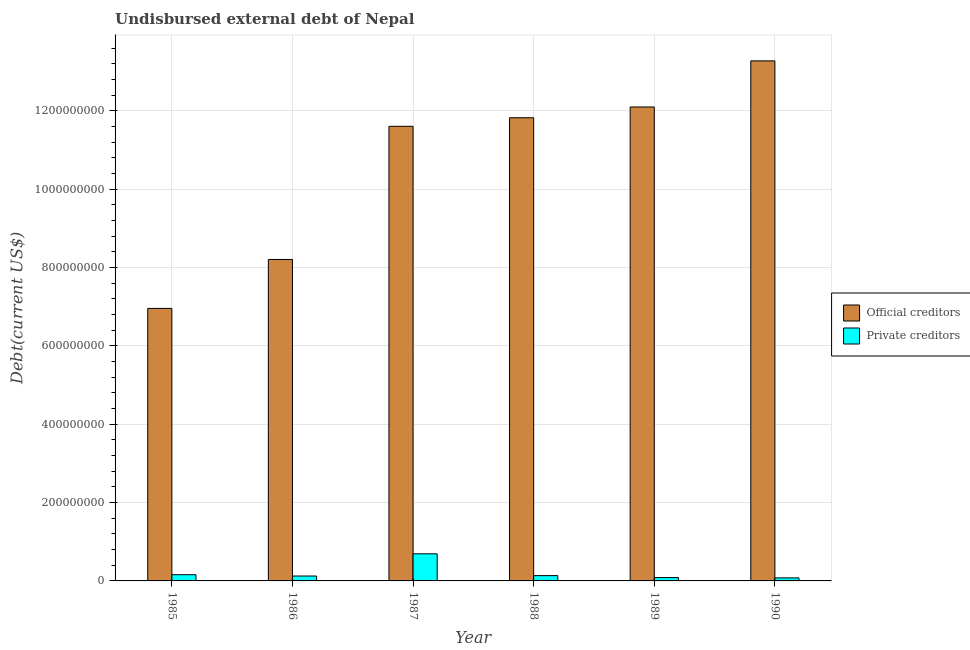Are the number of bars per tick equal to the number of legend labels?
Provide a succinct answer. Yes. Are the number of bars on each tick of the X-axis equal?
Your answer should be compact. Yes. How many bars are there on the 6th tick from the left?
Provide a succinct answer. 2. In how many cases, is the number of bars for a given year not equal to the number of legend labels?
Your answer should be compact. 0. What is the undisbursed external debt of private creditors in 1986?
Provide a short and direct response. 1.25e+07. Across all years, what is the maximum undisbursed external debt of private creditors?
Offer a terse response. 6.92e+07. Across all years, what is the minimum undisbursed external debt of private creditors?
Your response must be concise. 7.70e+06. In which year was the undisbursed external debt of private creditors minimum?
Make the answer very short. 1990. What is the total undisbursed external debt of official creditors in the graph?
Make the answer very short. 6.39e+09. What is the difference between the undisbursed external debt of private creditors in 1988 and that in 1990?
Ensure brevity in your answer.  5.80e+06. What is the difference between the undisbursed external debt of private creditors in 1990 and the undisbursed external debt of official creditors in 1986?
Ensure brevity in your answer.  -4.81e+06. What is the average undisbursed external debt of official creditors per year?
Provide a succinct answer. 1.07e+09. In how many years, is the undisbursed external debt of official creditors greater than 1240000000 US$?
Offer a terse response. 1. What is the ratio of the undisbursed external debt of private creditors in 1985 to that in 1989?
Keep it short and to the point. 1.86. Is the difference between the undisbursed external debt of private creditors in 1988 and 1990 greater than the difference between the undisbursed external debt of official creditors in 1988 and 1990?
Provide a short and direct response. No. What is the difference between the highest and the second highest undisbursed external debt of official creditors?
Your answer should be compact. 1.18e+08. What is the difference between the highest and the lowest undisbursed external debt of private creditors?
Your answer should be very brief. 6.15e+07. In how many years, is the undisbursed external debt of private creditors greater than the average undisbursed external debt of private creditors taken over all years?
Offer a very short reply. 1. What does the 2nd bar from the left in 1989 represents?
Keep it short and to the point. Private creditors. What does the 2nd bar from the right in 1990 represents?
Your answer should be compact. Official creditors. How many bars are there?
Keep it short and to the point. 12. How many years are there in the graph?
Give a very brief answer. 6. Does the graph contain grids?
Offer a very short reply. Yes. How many legend labels are there?
Offer a very short reply. 2. What is the title of the graph?
Offer a terse response. Undisbursed external debt of Nepal. What is the label or title of the Y-axis?
Your answer should be very brief. Debt(current US$). What is the Debt(current US$) in Official creditors in 1985?
Ensure brevity in your answer.  6.95e+08. What is the Debt(current US$) in Private creditors in 1985?
Ensure brevity in your answer.  1.59e+07. What is the Debt(current US$) in Official creditors in 1986?
Keep it short and to the point. 8.20e+08. What is the Debt(current US$) in Private creditors in 1986?
Provide a succinct answer. 1.25e+07. What is the Debt(current US$) of Official creditors in 1987?
Ensure brevity in your answer.  1.16e+09. What is the Debt(current US$) in Private creditors in 1987?
Your answer should be compact. 6.92e+07. What is the Debt(current US$) of Official creditors in 1988?
Offer a very short reply. 1.18e+09. What is the Debt(current US$) of Private creditors in 1988?
Provide a short and direct response. 1.35e+07. What is the Debt(current US$) of Official creditors in 1989?
Provide a short and direct response. 1.21e+09. What is the Debt(current US$) in Private creditors in 1989?
Keep it short and to the point. 8.53e+06. What is the Debt(current US$) of Official creditors in 1990?
Offer a terse response. 1.33e+09. What is the Debt(current US$) in Private creditors in 1990?
Make the answer very short. 7.70e+06. Across all years, what is the maximum Debt(current US$) of Official creditors?
Your answer should be very brief. 1.33e+09. Across all years, what is the maximum Debt(current US$) of Private creditors?
Your response must be concise. 6.92e+07. Across all years, what is the minimum Debt(current US$) of Official creditors?
Keep it short and to the point. 6.95e+08. Across all years, what is the minimum Debt(current US$) in Private creditors?
Make the answer very short. 7.70e+06. What is the total Debt(current US$) in Official creditors in the graph?
Your response must be concise. 6.39e+09. What is the total Debt(current US$) of Private creditors in the graph?
Your answer should be compact. 1.27e+08. What is the difference between the Debt(current US$) of Official creditors in 1985 and that in 1986?
Give a very brief answer. -1.25e+08. What is the difference between the Debt(current US$) in Private creditors in 1985 and that in 1986?
Ensure brevity in your answer.  3.41e+06. What is the difference between the Debt(current US$) in Official creditors in 1985 and that in 1987?
Provide a short and direct response. -4.65e+08. What is the difference between the Debt(current US$) in Private creditors in 1985 and that in 1987?
Ensure brevity in your answer.  -5.33e+07. What is the difference between the Debt(current US$) in Official creditors in 1985 and that in 1988?
Offer a terse response. -4.87e+08. What is the difference between the Debt(current US$) of Private creditors in 1985 and that in 1988?
Give a very brief answer. 2.41e+06. What is the difference between the Debt(current US$) of Official creditors in 1985 and that in 1989?
Your answer should be compact. -5.14e+08. What is the difference between the Debt(current US$) of Private creditors in 1985 and that in 1989?
Ensure brevity in your answer.  7.38e+06. What is the difference between the Debt(current US$) of Official creditors in 1985 and that in 1990?
Your response must be concise. -6.32e+08. What is the difference between the Debt(current US$) in Private creditors in 1985 and that in 1990?
Your answer should be compact. 8.21e+06. What is the difference between the Debt(current US$) of Official creditors in 1986 and that in 1987?
Provide a succinct answer. -3.40e+08. What is the difference between the Debt(current US$) in Private creditors in 1986 and that in 1987?
Provide a short and direct response. -5.67e+07. What is the difference between the Debt(current US$) of Official creditors in 1986 and that in 1988?
Keep it short and to the point. -3.62e+08. What is the difference between the Debt(current US$) in Private creditors in 1986 and that in 1988?
Provide a short and direct response. -9.94e+05. What is the difference between the Debt(current US$) in Official creditors in 1986 and that in 1989?
Provide a short and direct response. -3.89e+08. What is the difference between the Debt(current US$) of Private creditors in 1986 and that in 1989?
Give a very brief answer. 3.97e+06. What is the difference between the Debt(current US$) in Official creditors in 1986 and that in 1990?
Offer a terse response. -5.07e+08. What is the difference between the Debt(current US$) of Private creditors in 1986 and that in 1990?
Your answer should be compact. 4.81e+06. What is the difference between the Debt(current US$) of Official creditors in 1987 and that in 1988?
Keep it short and to the point. -2.18e+07. What is the difference between the Debt(current US$) in Private creditors in 1987 and that in 1988?
Offer a very short reply. 5.57e+07. What is the difference between the Debt(current US$) of Official creditors in 1987 and that in 1989?
Offer a very short reply. -4.93e+07. What is the difference between the Debt(current US$) in Private creditors in 1987 and that in 1989?
Offer a very short reply. 6.06e+07. What is the difference between the Debt(current US$) of Official creditors in 1987 and that in 1990?
Give a very brief answer. -1.67e+08. What is the difference between the Debt(current US$) of Private creditors in 1987 and that in 1990?
Ensure brevity in your answer.  6.15e+07. What is the difference between the Debt(current US$) in Official creditors in 1988 and that in 1989?
Provide a short and direct response. -2.75e+07. What is the difference between the Debt(current US$) of Private creditors in 1988 and that in 1989?
Provide a short and direct response. 4.96e+06. What is the difference between the Debt(current US$) in Official creditors in 1988 and that in 1990?
Your answer should be compact. -1.45e+08. What is the difference between the Debt(current US$) in Private creditors in 1988 and that in 1990?
Provide a succinct answer. 5.80e+06. What is the difference between the Debt(current US$) of Official creditors in 1989 and that in 1990?
Provide a succinct answer. -1.18e+08. What is the difference between the Debt(current US$) in Private creditors in 1989 and that in 1990?
Offer a terse response. 8.39e+05. What is the difference between the Debt(current US$) of Official creditors in 1985 and the Debt(current US$) of Private creditors in 1986?
Offer a terse response. 6.83e+08. What is the difference between the Debt(current US$) in Official creditors in 1985 and the Debt(current US$) in Private creditors in 1987?
Your answer should be very brief. 6.26e+08. What is the difference between the Debt(current US$) in Official creditors in 1985 and the Debt(current US$) in Private creditors in 1988?
Provide a succinct answer. 6.82e+08. What is the difference between the Debt(current US$) of Official creditors in 1985 and the Debt(current US$) of Private creditors in 1989?
Your answer should be compact. 6.87e+08. What is the difference between the Debt(current US$) of Official creditors in 1985 and the Debt(current US$) of Private creditors in 1990?
Offer a very short reply. 6.88e+08. What is the difference between the Debt(current US$) in Official creditors in 1986 and the Debt(current US$) in Private creditors in 1987?
Provide a succinct answer. 7.51e+08. What is the difference between the Debt(current US$) in Official creditors in 1986 and the Debt(current US$) in Private creditors in 1988?
Provide a succinct answer. 8.07e+08. What is the difference between the Debt(current US$) in Official creditors in 1986 and the Debt(current US$) in Private creditors in 1989?
Give a very brief answer. 8.12e+08. What is the difference between the Debt(current US$) in Official creditors in 1986 and the Debt(current US$) in Private creditors in 1990?
Your answer should be very brief. 8.13e+08. What is the difference between the Debt(current US$) of Official creditors in 1987 and the Debt(current US$) of Private creditors in 1988?
Your answer should be very brief. 1.15e+09. What is the difference between the Debt(current US$) of Official creditors in 1987 and the Debt(current US$) of Private creditors in 1989?
Provide a short and direct response. 1.15e+09. What is the difference between the Debt(current US$) of Official creditors in 1987 and the Debt(current US$) of Private creditors in 1990?
Your answer should be compact. 1.15e+09. What is the difference between the Debt(current US$) of Official creditors in 1988 and the Debt(current US$) of Private creditors in 1989?
Offer a very short reply. 1.17e+09. What is the difference between the Debt(current US$) of Official creditors in 1988 and the Debt(current US$) of Private creditors in 1990?
Provide a succinct answer. 1.17e+09. What is the difference between the Debt(current US$) in Official creditors in 1989 and the Debt(current US$) in Private creditors in 1990?
Provide a short and direct response. 1.20e+09. What is the average Debt(current US$) of Official creditors per year?
Your answer should be compact. 1.07e+09. What is the average Debt(current US$) in Private creditors per year?
Your answer should be very brief. 2.12e+07. In the year 1985, what is the difference between the Debt(current US$) of Official creditors and Debt(current US$) of Private creditors?
Offer a very short reply. 6.80e+08. In the year 1986, what is the difference between the Debt(current US$) in Official creditors and Debt(current US$) in Private creditors?
Make the answer very short. 8.08e+08. In the year 1987, what is the difference between the Debt(current US$) in Official creditors and Debt(current US$) in Private creditors?
Offer a terse response. 1.09e+09. In the year 1988, what is the difference between the Debt(current US$) in Official creditors and Debt(current US$) in Private creditors?
Offer a very short reply. 1.17e+09. In the year 1989, what is the difference between the Debt(current US$) in Official creditors and Debt(current US$) in Private creditors?
Your response must be concise. 1.20e+09. In the year 1990, what is the difference between the Debt(current US$) in Official creditors and Debt(current US$) in Private creditors?
Provide a short and direct response. 1.32e+09. What is the ratio of the Debt(current US$) in Official creditors in 1985 to that in 1986?
Your response must be concise. 0.85. What is the ratio of the Debt(current US$) of Private creditors in 1985 to that in 1986?
Give a very brief answer. 1.27. What is the ratio of the Debt(current US$) in Official creditors in 1985 to that in 1987?
Offer a terse response. 0.6. What is the ratio of the Debt(current US$) of Private creditors in 1985 to that in 1987?
Your answer should be very brief. 0.23. What is the ratio of the Debt(current US$) of Official creditors in 1985 to that in 1988?
Your response must be concise. 0.59. What is the ratio of the Debt(current US$) of Private creditors in 1985 to that in 1988?
Provide a succinct answer. 1.18. What is the ratio of the Debt(current US$) of Official creditors in 1985 to that in 1989?
Give a very brief answer. 0.57. What is the ratio of the Debt(current US$) in Private creditors in 1985 to that in 1989?
Your response must be concise. 1.86. What is the ratio of the Debt(current US$) of Official creditors in 1985 to that in 1990?
Offer a terse response. 0.52. What is the ratio of the Debt(current US$) of Private creditors in 1985 to that in 1990?
Provide a succinct answer. 2.07. What is the ratio of the Debt(current US$) of Official creditors in 1986 to that in 1987?
Provide a short and direct response. 0.71. What is the ratio of the Debt(current US$) in Private creditors in 1986 to that in 1987?
Your answer should be compact. 0.18. What is the ratio of the Debt(current US$) of Official creditors in 1986 to that in 1988?
Give a very brief answer. 0.69. What is the ratio of the Debt(current US$) in Private creditors in 1986 to that in 1988?
Provide a succinct answer. 0.93. What is the ratio of the Debt(current US$) of Official creditors in 1986 to that in 1989?
Ensure brevity in your answer.  0.68. What is the ratio of the Debt(current US$) in Private creditors in 1986 to that in 1989?
Provide a short and direct response. 1.46. What is the ratio of the Debt(current US$) in Official creditors in 1986 to that in 1990?
Give a very brief answer. 0.62. What is the ratio of the Debt(current US$) of Private creditors in 1986 to that in 1990?
Ensure brevity in your answer.  1.62. What is the ratio of the Debt(current US$) in Official creditors in 1987 to that in 1988?
Provide a succinct answer. 0.98. What is the ratio of the Debt(current US$) of Private creditors in 1987 to that in 1988?
Ensure brevity in your answer.  5.13. What is the ratio of the Debt(current US$) in Official creditors in 1987 to that in 1989?
Make the answer very short. 0.96. What is the ratio of the Debt(current US$) in Private creditors in 1987 to that in 1989?
Ensure brevity in your answer.  8.1. What is the ratio of the Debt(current US$) in Official creditors in 1987 to that in 1990?
Give a very brief answer. 0.87. What is the ratio of the Debt(current US$) in Private creditors in 1987 to that in 1990?
Ensure brevity in your answer.  8.99. What is the ratio of the Debt(current US$) in Official creditors in 1988 to that in 1989?
Offer a very short reply. 0.98. What is the ratio of the Debt(current US$) in Private creditors in 1988 to that in 1989?
Make the answer very short. 1.58. What is the ratio of the Debt(current US$) of Official creditors in 1988 to that in 1990?
Give a very brief answer. 0.89. What is the ratio of the Debt(current US$) in Private creditors in 1988 to that in 1990?
Make the answer very short. 1.75. What is the ratio of the Debt(current US$) in Official creditors in 1989 to that in 1990?
Make the answer very short. 0.91. What is the ratio of the Debt(current US$) in Private creditors in 1989 to that in 1990?
Provide a succinct answer. 1.11. What is the difference between the highest and the second highest Debt(current US$) in Official creditors?
Provide a short and direct response. 1.18e+08. What is the difference between the highest and the second highest Debt(current US$) of Private creditors?
Ensure brevity in your answer.  5.33e+07. What is the difference between the highest and the lowest Debt(current US$) in Official creditors?
Provide a succinct answer. 6.32e+08. What is the difference between the highest and the lowest Debt(current US$) in Private creditors?
Your answer should be very brief. 6.15e+07. 